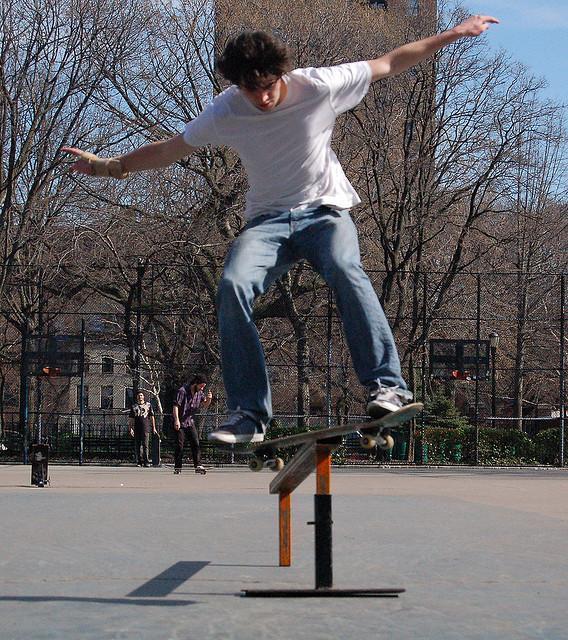How many people are there?
Give a very brief answer. 2. 